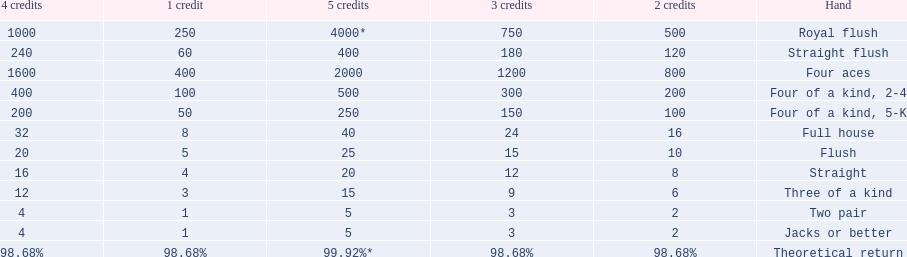What is the values in the 5 credits area? 4000*, 400, 2000, 500, 250, 40, 25, 20, 15, 5, 5. Which of these is for a four of a kind? 500, 250. What is the higher value? 500. What hand is this for Four of a kind, 2-4. 